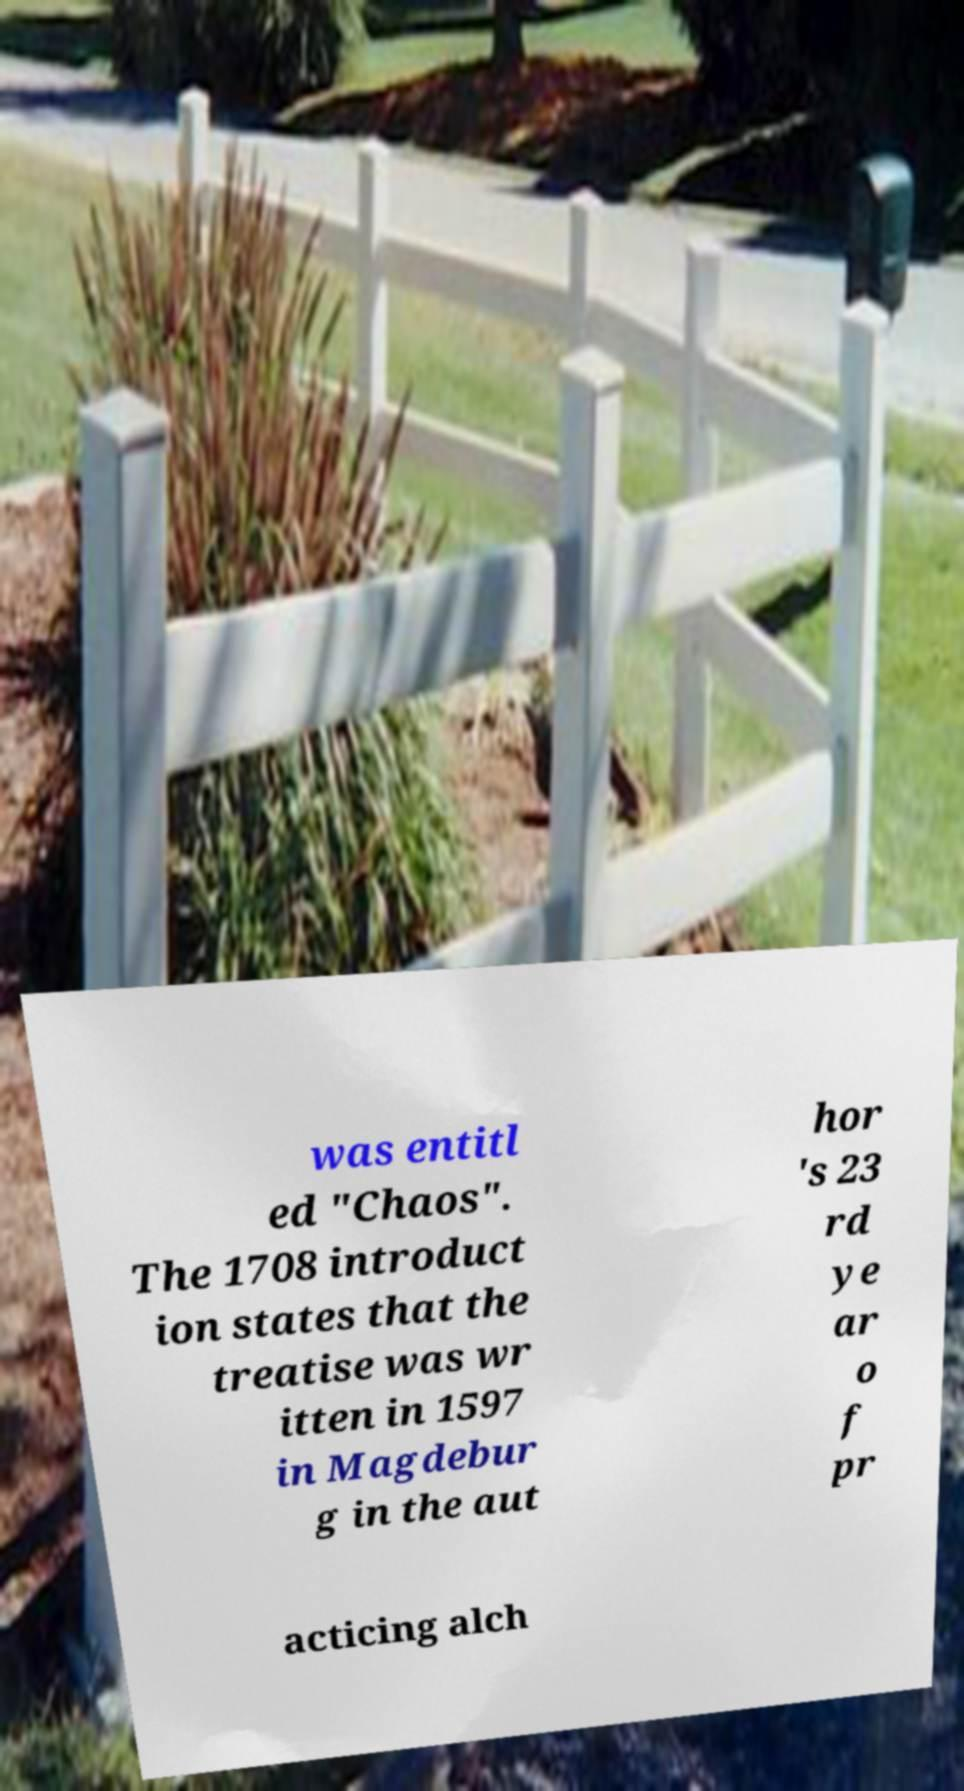Could you assist in decoding the text presented in this image and type it out clearly? was entitl ed "Chaos". The 1708 introduct ion states that the treatise was wr itten in 1597 in Magdebur g in the aut hor 's 23 rd ye ar o f pr acticing alch 